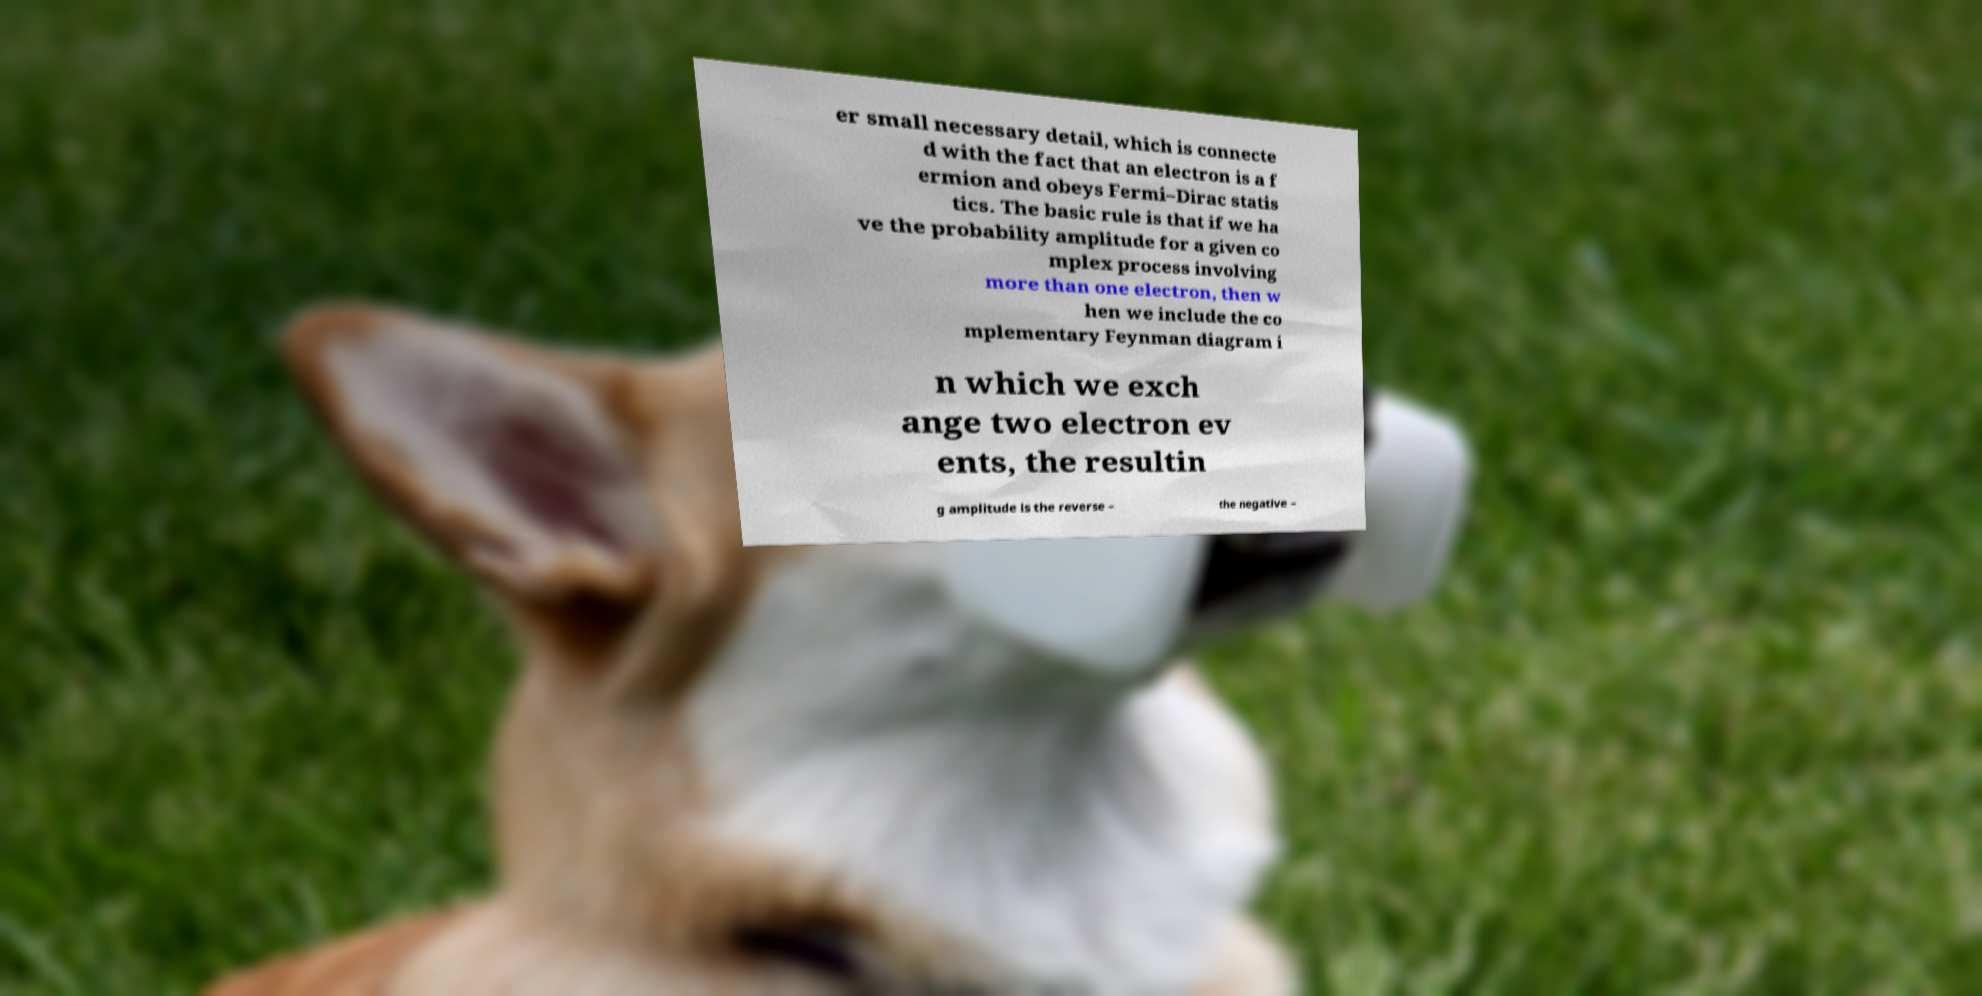There's text embedded in this image that I need extracted. Can you transcribe it verbatim? er small necessary detail, which is connecte d with the fact that an electron is a f ermion and obeys Fermi–Dirac statis tics. The basic rule is that if we ha ve the probability amplitude for a given co mplex process involving more than one electron, then w hen we include the co mplementary Feynman diagram i n which we exch ange two electron ev ents, the resultin g amplitude is the reverse – the negative – 